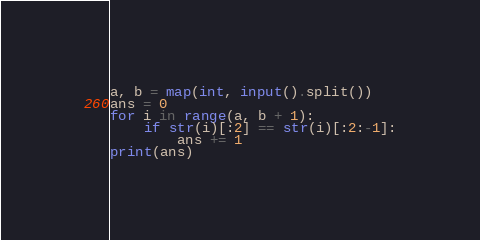<code> <loc_0><loc_0><loc_500><loc_500><_Python_>a, b = map(int, input().split())
ans = 0
for i in range(a, b + 1):
    if str(i)[:2] == str(i)[:2:-1]:
        ans += 1
print(ans)
</code> 